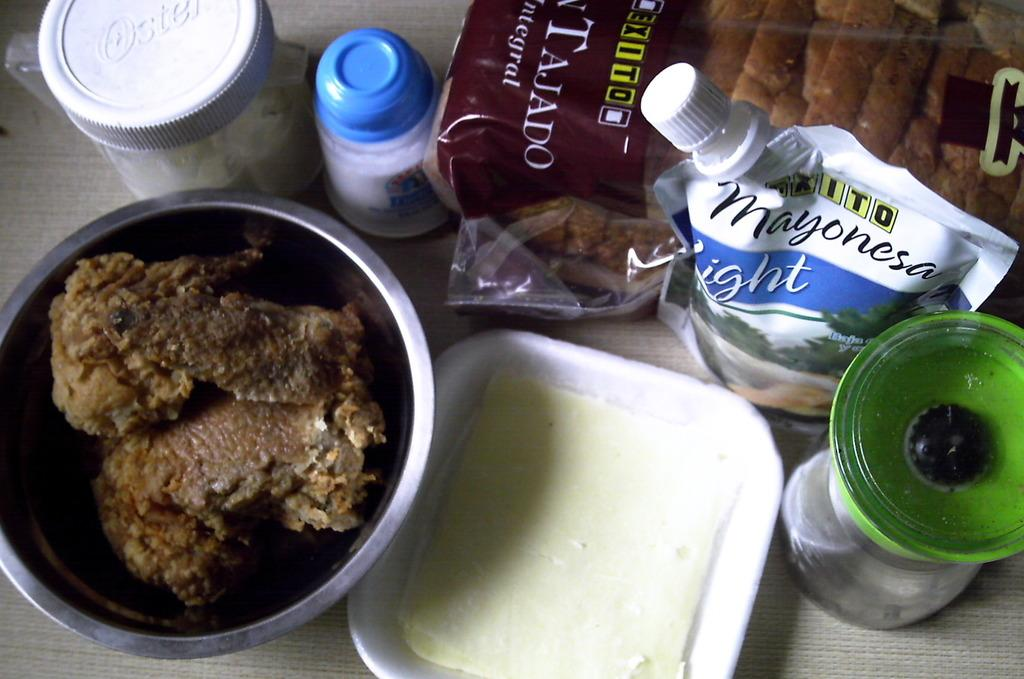<image>
Share a concise interpretation of the image provided. Mayonesa LIght next to some chicken and other ingredients. 